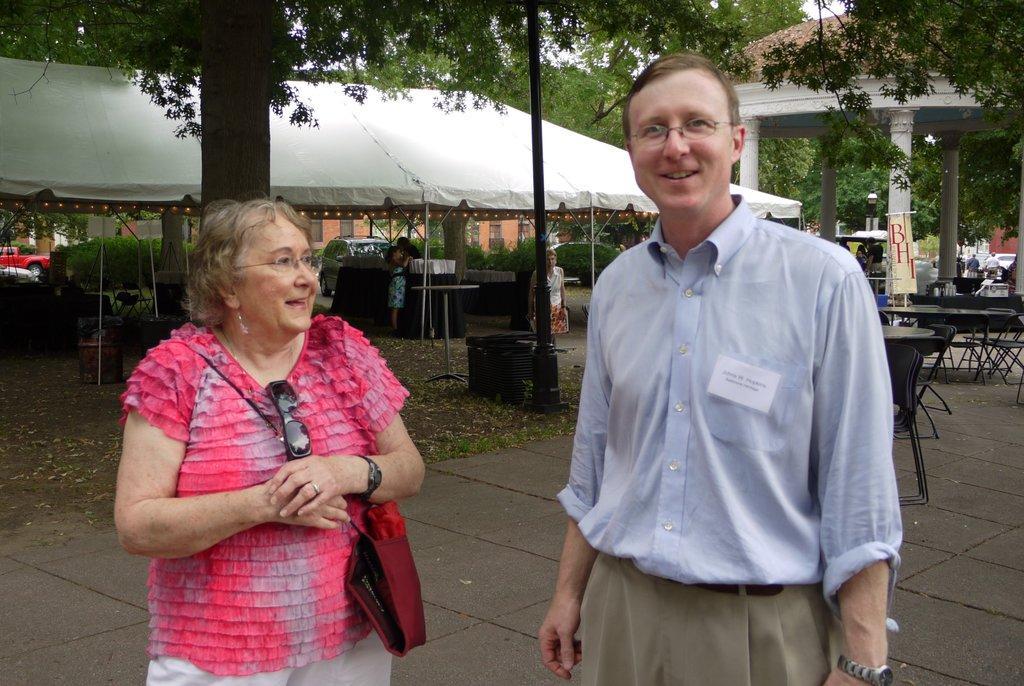Please provide a concise description of this image. In front of the picture, we see the man and the women are standing. Both of them are wearing the spectacles and they are smiling. The man is posing for the photo. The man is wearing a handbag. On the right side, we see many chairs and tables. Behind that, we see a board in which color with some text written. In the middle, we see a pole. Behind that, we see three people are standing. Beside them, we see the tables. On the right side, we see the pillars and the people are standing. We see the cars in the background. On the left side, we see the chairs and the tables are placed under the white tent. There are trees, buildings and cars in the background. 